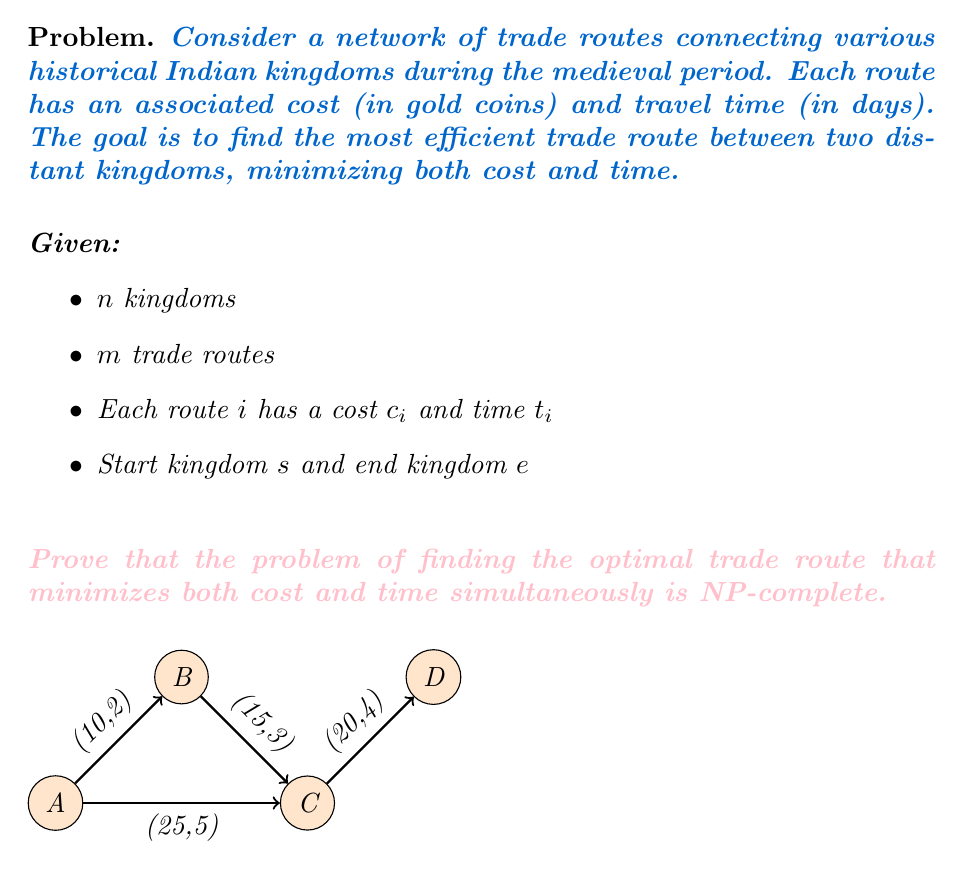Can you answer this question? To prove that this problem is NP-complete, we need to show that it is both in NP and NP-hard.

Step 1: Show the problem is in NP
- A solution can be verified in polynomial time by summing up the costs and times of the chosen routes and checking if they form a valid path from $s$ to $e$.

Step 2: Show the problem is NP-hard by reducing a known NP-complete problem to it
- We can reduce the Traveling Salesman Problem (TSP) to our trade route optimization problem.

Reduction:
1. For each city in TSP, create a corresponding kingdom.
2. For each edge in TSP with distance $d$, create a trade route with cost $c = d$ and time $t = d$.
3. Set the start and end kingdoms as the same kingdom (corresponding to the start/end city in TSP).

Now, finding the optimal trade route that minimizes both cost and time is equivalent to finding the shortest Hamiltonian cycle in TSP.

Step 3: Prove the reduction is polynomial-time
- The reduction creates $n$ kingdoms and $m$ trade routes, where $n$ and $m$ are the number of cities and edges in the TSP instance, respectively.
- This transformation can be done in $O(n + m)$ time, which is polynomial.

Step 4: Prove the reduction is correct
- Any solution to the TSP instance corresponds to a valid solution in our trade route problem, and vice versa.
- The optimal solution in TSP (shortest Hamiltonian cycle) corresponds to the optimal trade route (minimizing both cost and time).

Since we have shown that:
1. The problem is in NP
2. A known NP-complete problem (TSP) can be reduced to it in polynomial time
3. The reduction is correct

We can conclude that the trade route optimization problem is NP-complete.
Answer: NP-complete 